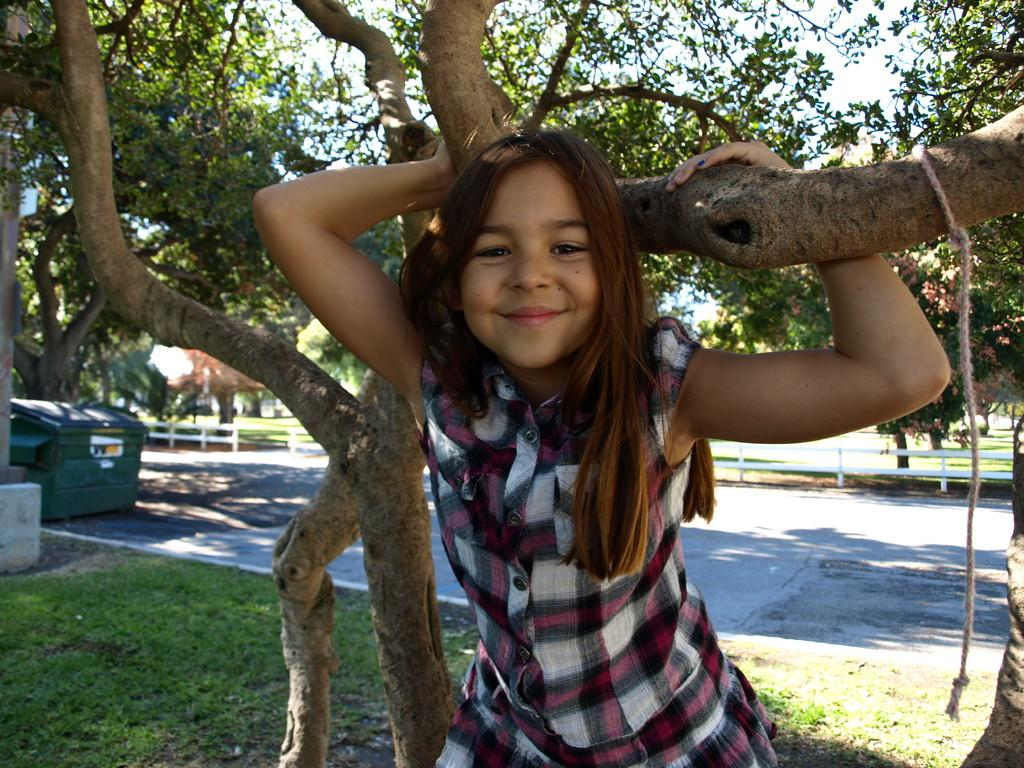What is the main subject of the image? The main subject of the image is a kid. Where is the kid located in the image? The kid is on a tree in the image. What can be seen in the background of the image? There are trees and plants visible in the background of the image. What type of drum is the grandfather playing in the image? There is no drum or grandfather present in the image; it features a kid on a tree with trees and plants in the background. 